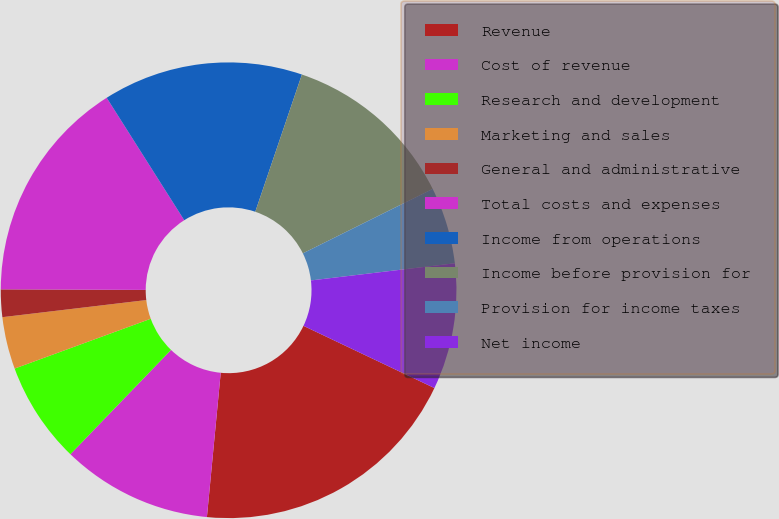Convert chart to OTSL. <chart><loc_0><loc_0><loc_500><loc_500><pie_chart><fcel>Revenue<fcel>Cost of revenue<fcel>Research and development<fcel>Marketing and sales<fcel>General and administrative<fcel>Total costs and expenses<fcel>Income from operations<fcel>Income before provision for<fcel>Provision for income taxes<fcel>Net income<nl><fcel>19.46%<fcel>10.7%<fcel>7.2%<fcel>3.7%<fcel>1.95%<fcel>15.95%<fcel>14.2%<fcel>12.45%<fcel>5.45%<fcel>8.95%<nl></chart> 